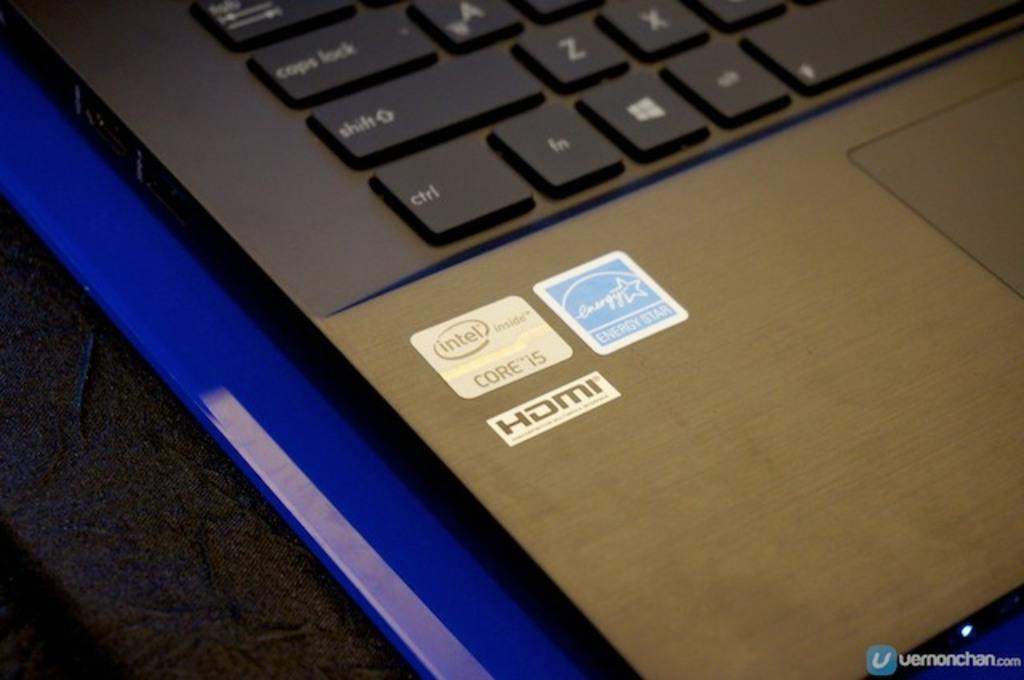<image>
Write a terse but informative summary of the picture. A close up of a laptop with a sticker that says intel and HDMI. 